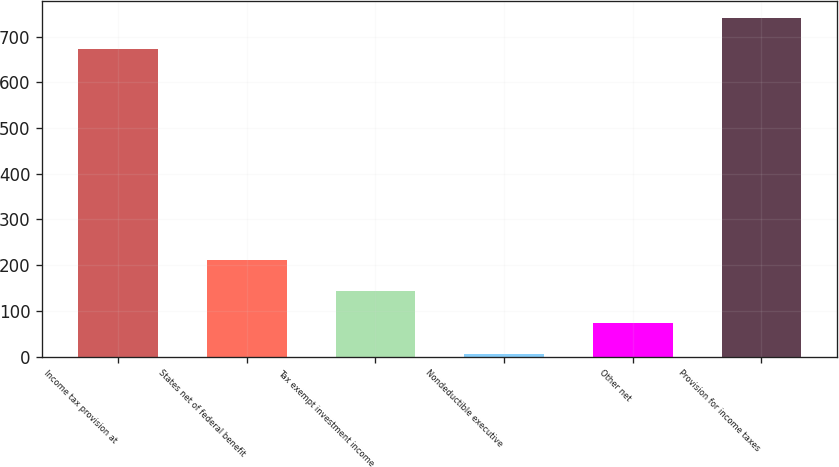Convert chart to OTSL. <chart><loc_0><loc_0><loc_500><loc_500><bar_chart><fcel>Income tax provision at<fcel>States net of federal benefit<fcel>Tax exempt investment income<fcel>Nondeductible executive<fcel>Other net<fcel>Provision for income taxes<nl><fcel>672<fcel>211.2<fcel>142.8<fcel>6<fcel>74.4<fcel>740.4<nl></chart> 